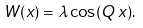Convert formula to latex. <formula><loc_0><loc_0><loc_500><loc_500>W ( x ) = \lambda \cos ( Q \, x ) .</formula> 